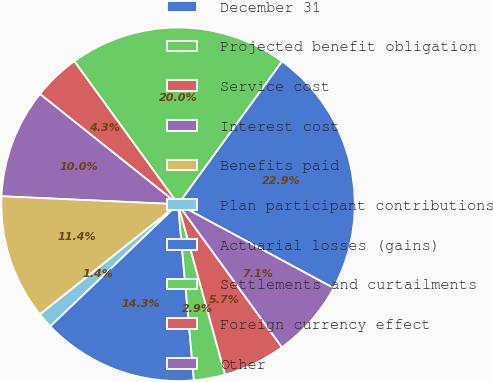<chart> <loc_0><loc_0><loc_500><loc_500><pie_chart><fcel>December 31<fcel>Projected benefit obligation<fcel>Service cost<fcel>Interest cost<fcel>Benefits paid<fcel>Plan participant contributions<fcel>Actuarial losses (gains)<fcel>Settlements and curtailments<fcel>Foreign currency effect<fcel>Other<nl><fcel>22.86%<fcel>20.0%<fcel>4.29%<fcel>10.0%<fcel>11.43%<fcel>1.43%<fcel>14.29%<fcel>2.86%<fcel>5.71%<fcel>7.14%<nl></chart> 